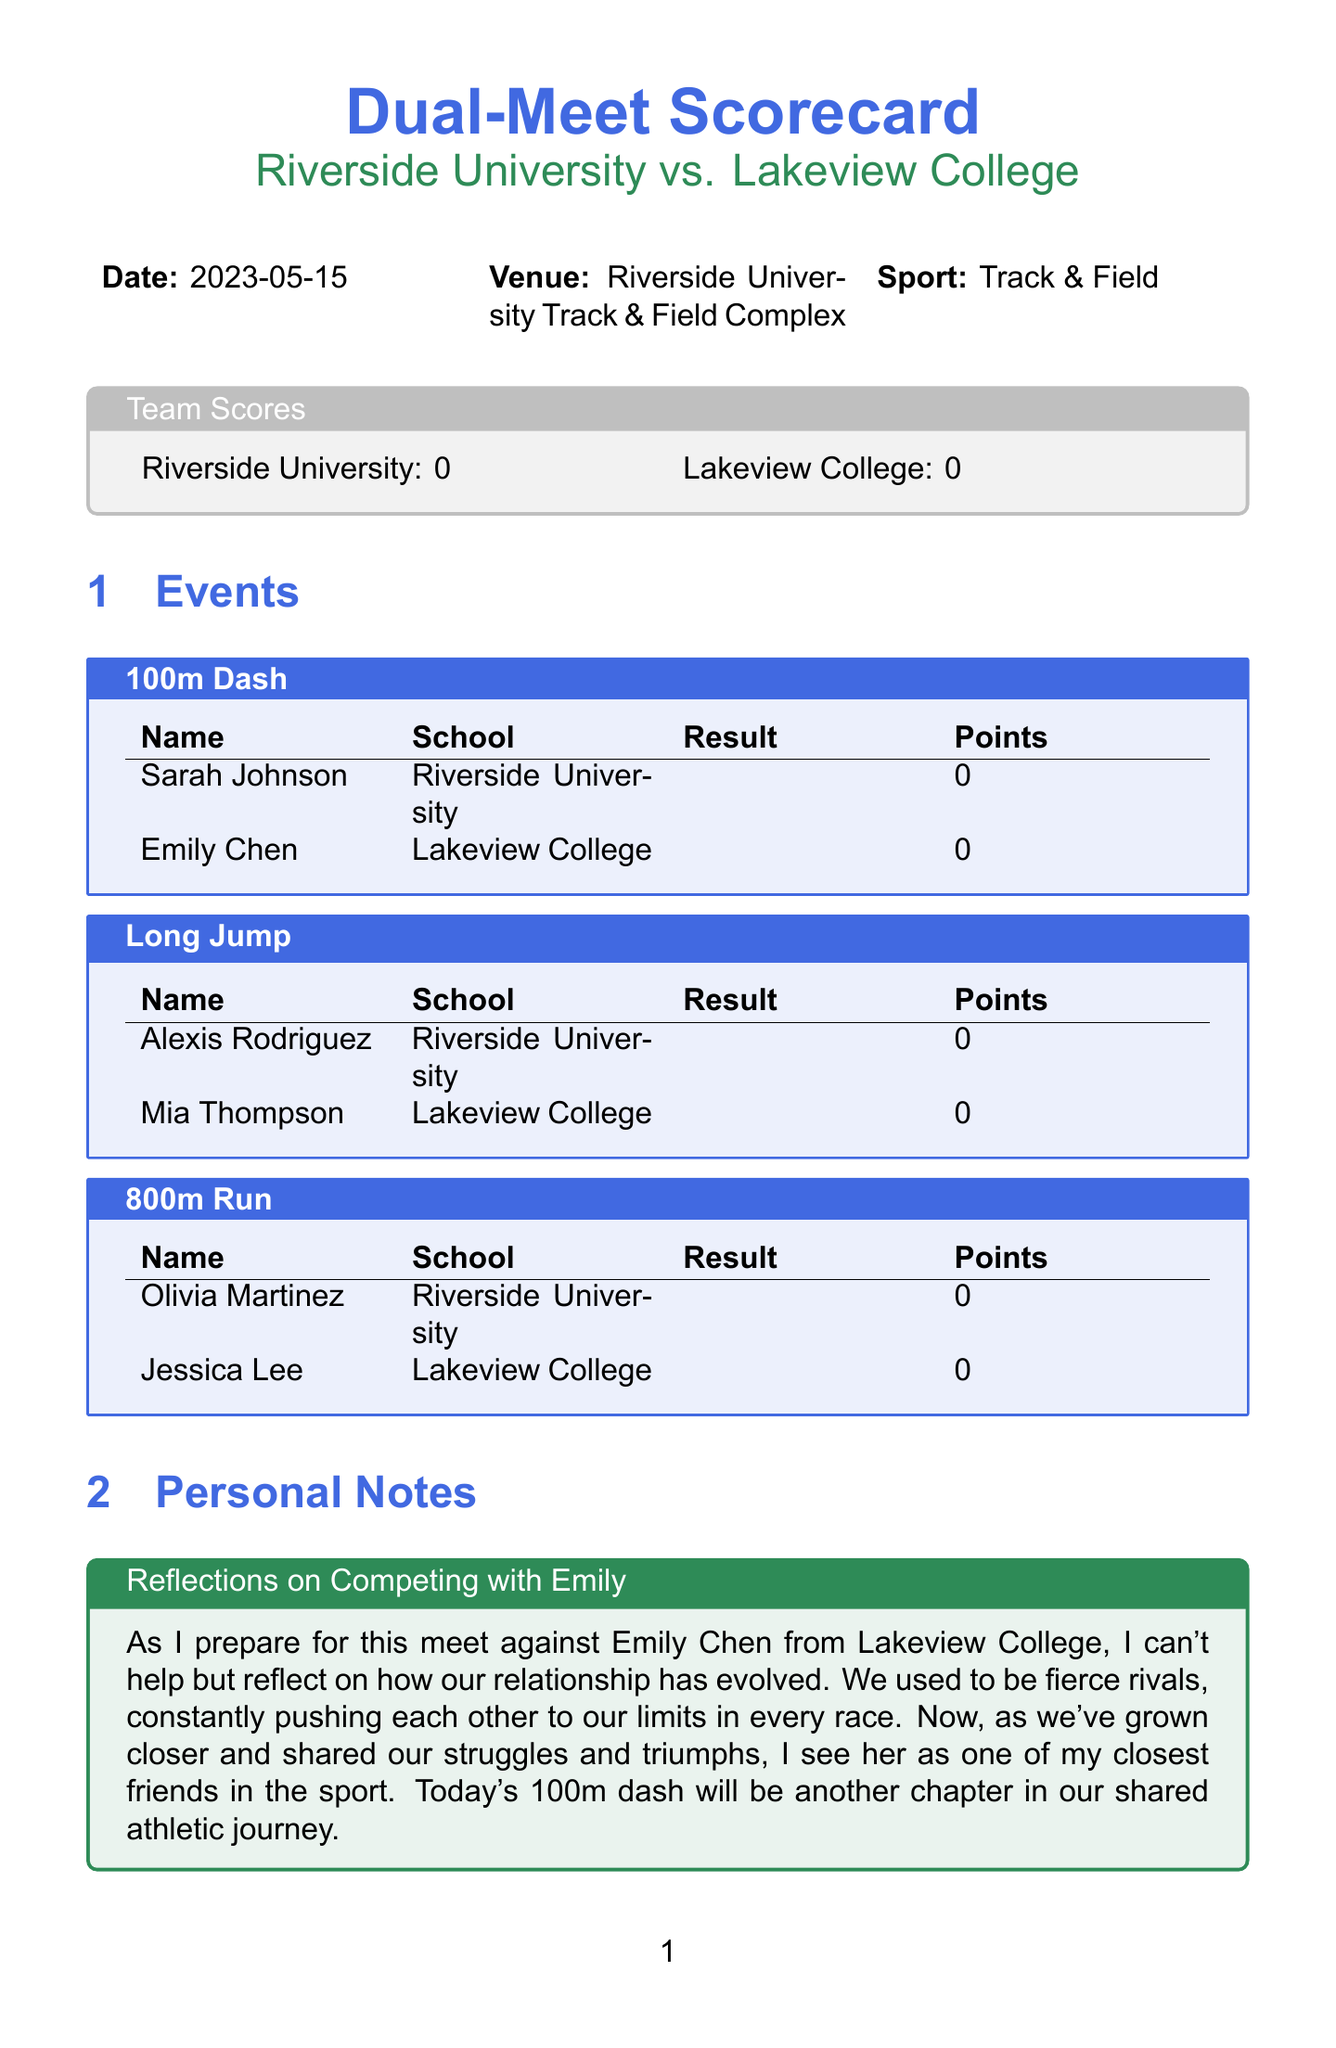What is the date of the meet? The date of the meet is explicitly stated in the document as "2023-05-15."
Answer: 2023-05-15 What is the venue for the meet? The venue for the meet is specified in the document, which is "Riverside University Track & Field Complex."
Answer: Riverside University Track & Field Complex Who is competing from Riverside University in the 800m Run? The document lists "Olivia Martinez" as the participant from Riverside University in the 800m Run event.
Answer: Olivia Martinez What is one strength of Lakeview College? The document outlines strengths for Lakeview College, one of which is "Dominant in distance events."
Answer: Dominant in distance events What is an area for improvement for Riverside University? The document mentions that "Middle distance runners need more endurance training" as an area for improvement for Riverside University.
Answer: Middle distance runners need more endurance training What is the title of the personal notes section? The personal notes section is titled "Reflections on Competing with Emily."
Answer: Reflections on Competing with Emily What sport is being competed in? The document specifies that the sport type is "Track & Field."
Answer: Track & Field Who wrote the post-meet analysis? The post-meet analysis doesn't specify a name but refers to "Emily" as someone involved, making it more relational.
Answer: Emily What points did Sarah Johnson earn in the 100m Dash? The document shows "points" for Sarah Johnson in the 100m Dash as "0."
Answer: 0 